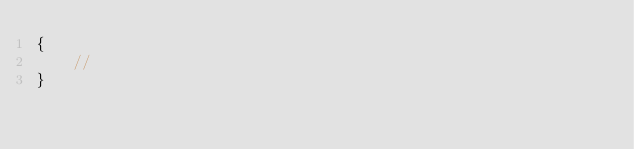<code> <loc_0><loc_0><loc_500><loc_500><_PHP_>{
    //
}
</code> 